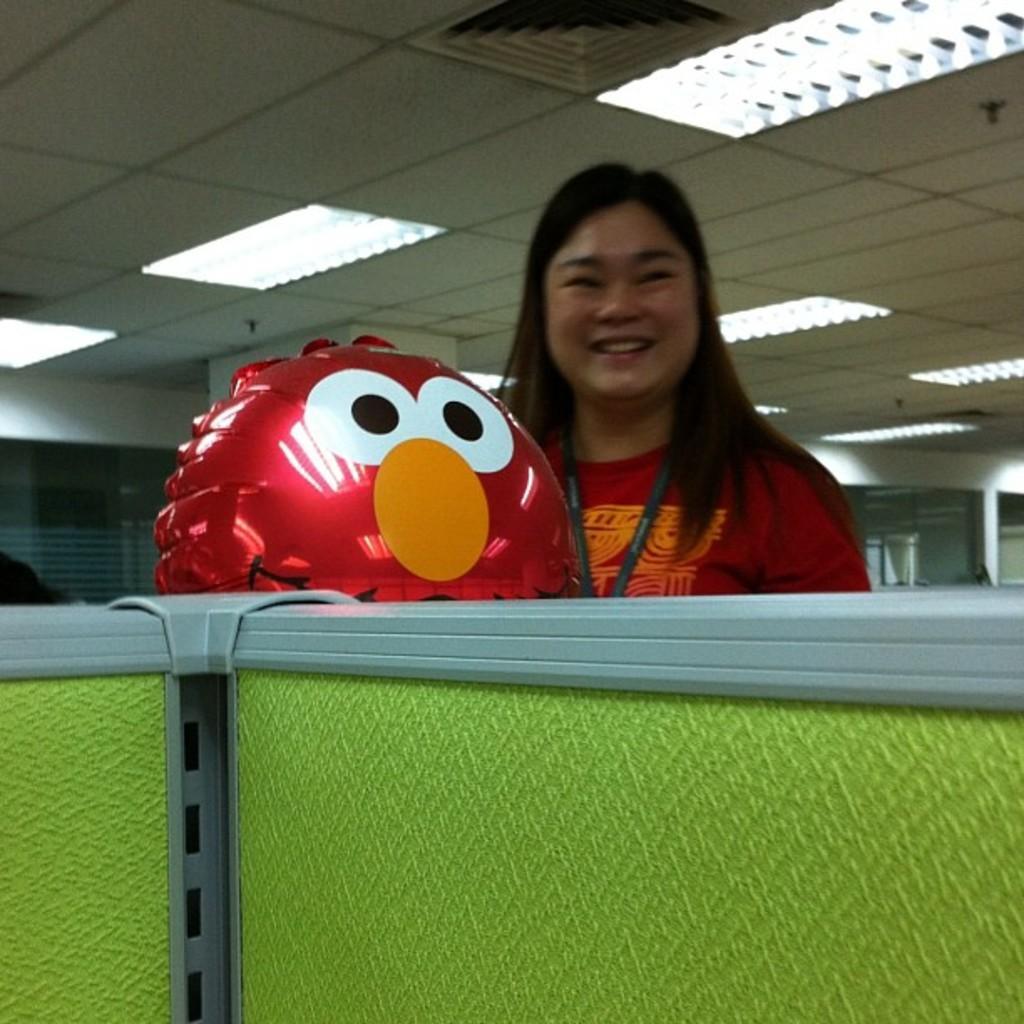In one or two sentences, can you explain what this image depicts? In the center of the image we can see a lady standing and smiling and there is a balloon. At the bottom we can see a cubicle. In the background there are walls. At the top there are lights. 